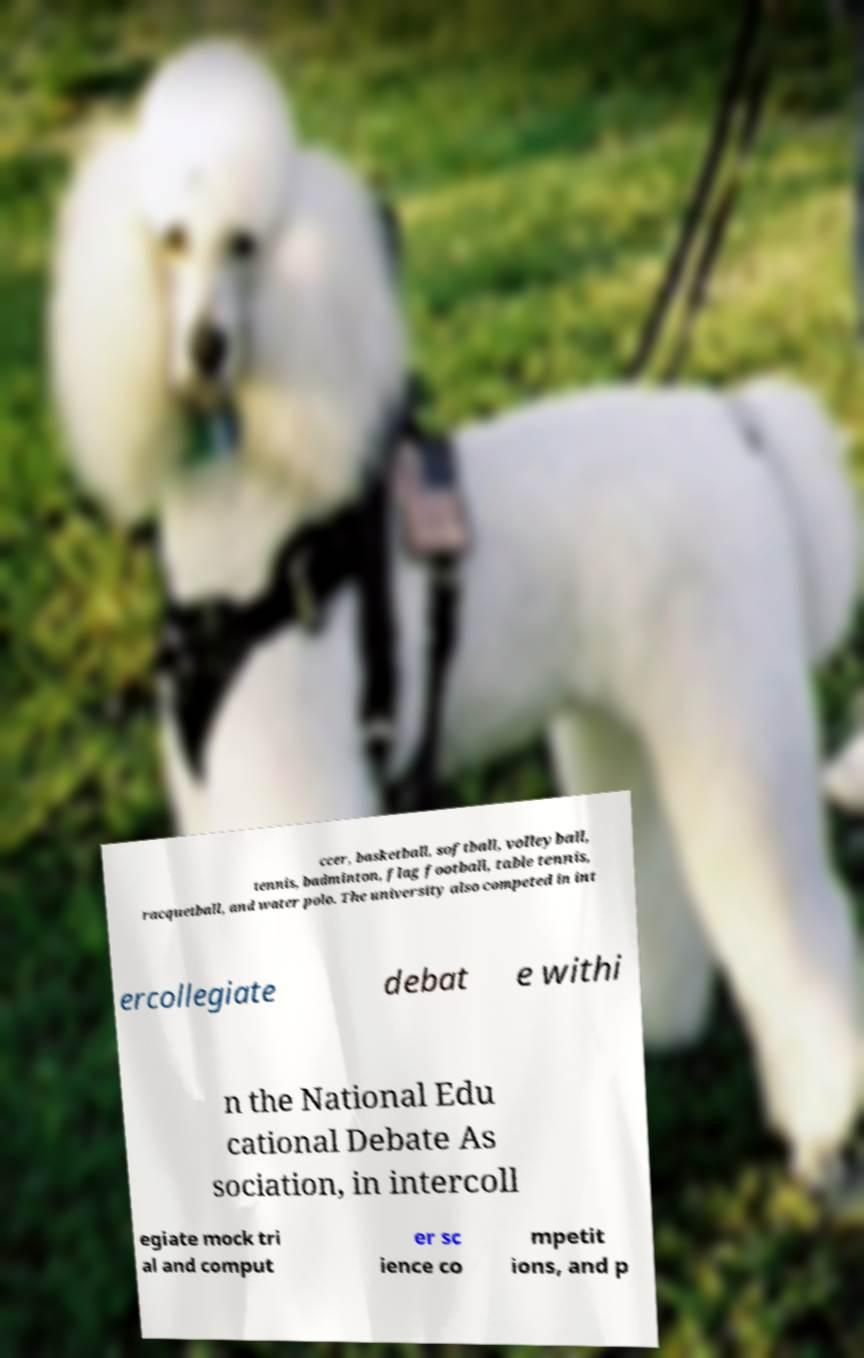For documentation purposes, I need the text within this image transcribed. Could you provide that? ccer, basketball, softball, volleyball, tennis, badminton, flag football, table tennis, racquetball, and water polo. The university also competed in int ercollegiate debat e withi n the National Edu cational Debate As sociation, in intercoll egiate mock tri al and comput er sc ience co mpetit ions, and p 